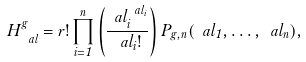<formula> <loc_0><loc_0><loc_500><loc_500>H ^ { g } _ { \ a l } = r ! \prod _ { i = 1 } ^ { n } \left ( \frac { \ a l _ { i } ^ { \ a l _ { i } } } { \ a l _ { i } ! } \right ) P _ { g , n } ( \ a l _ { 1 } , \dots , \ a l _ { n } ) ,</formula> 